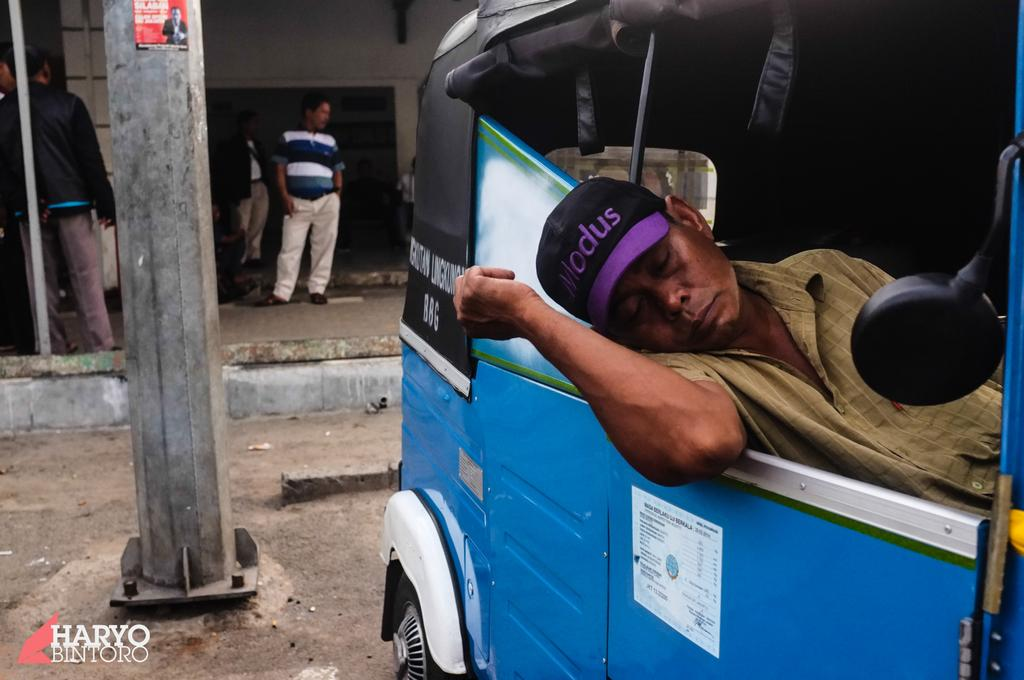What is the man doing in the image? The man is laying inside an auto rickshaw. What can be seen on the left side of the image? There is a street pole on the left side of the image. What is happening in the background of the image? There are people standing in front of a wall in the background of the image. What type of pencil can be seen on the ground in the image? There is no pencil present on the ground in the image. Is there any grass visible in the image? No, there is no grass visible in the image. 